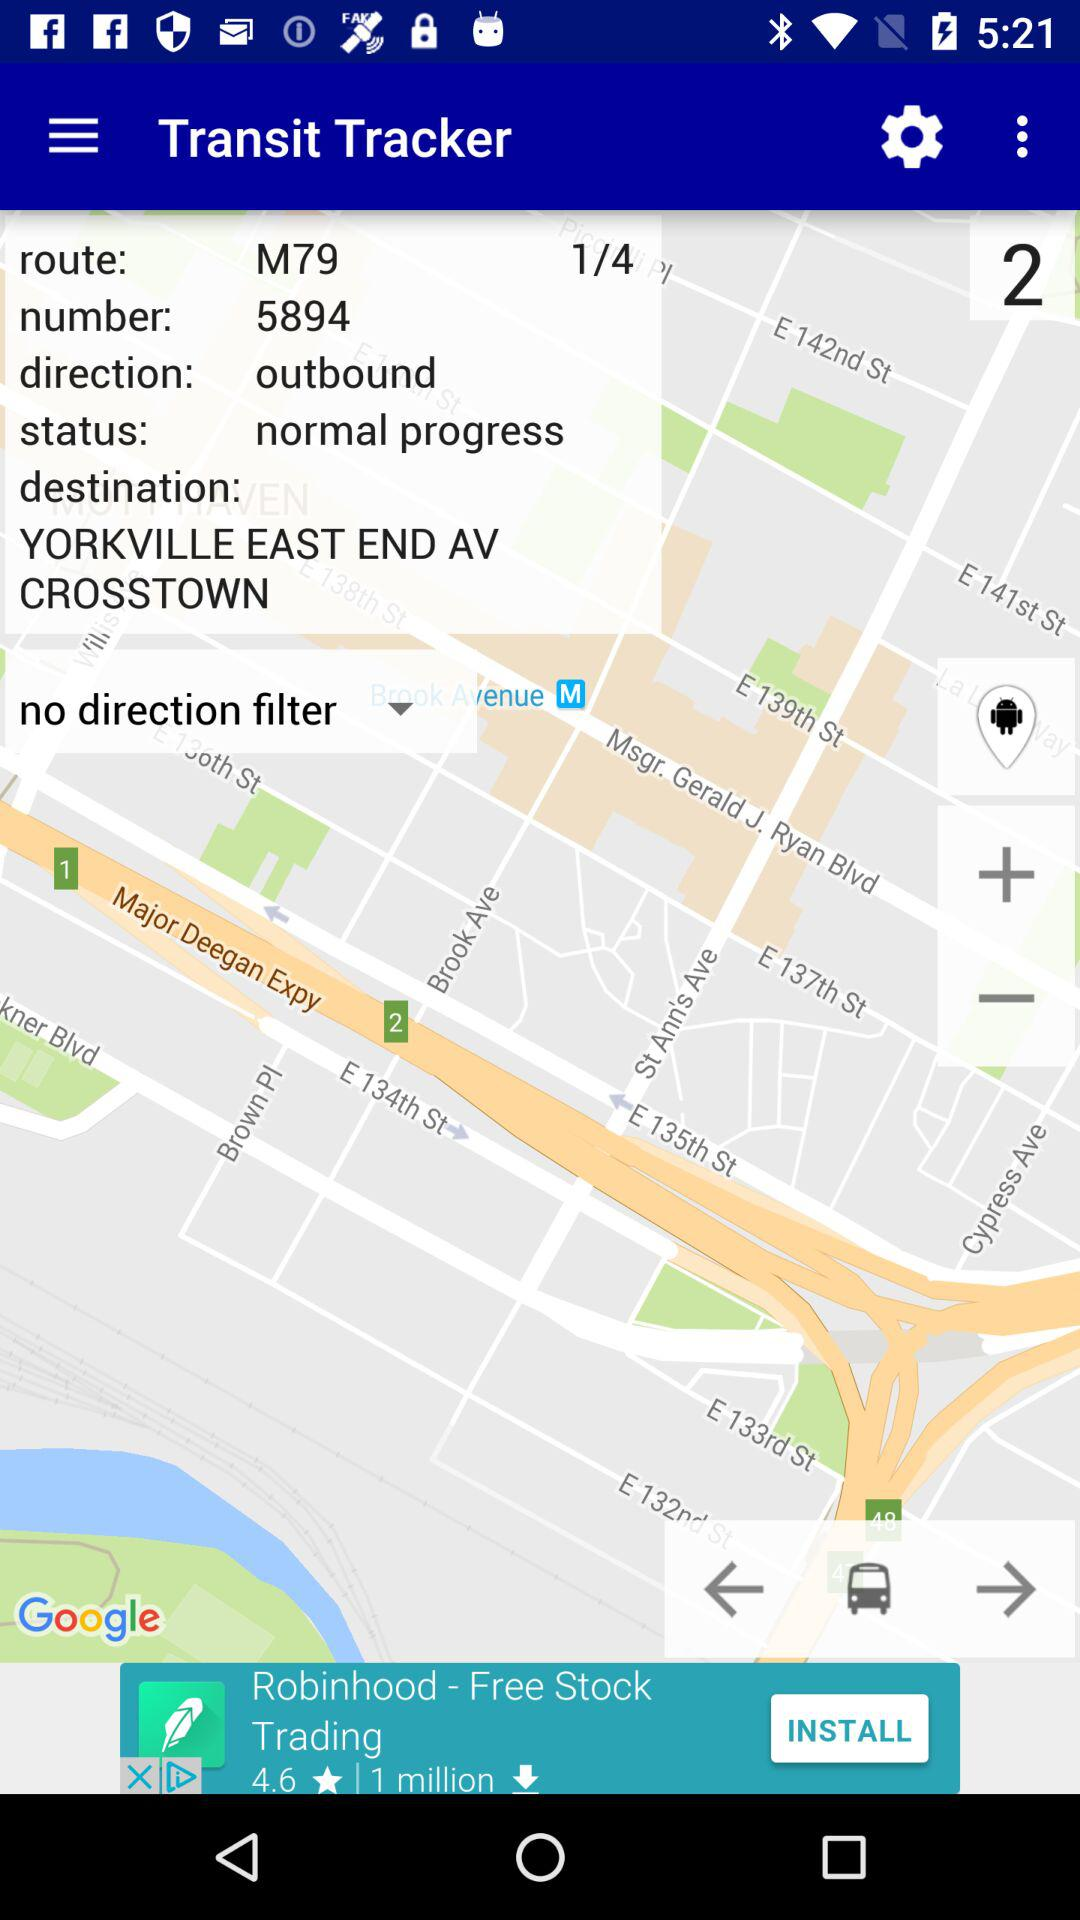What is the destination? The destination is Yorkville East End Avenue Crosstown. 